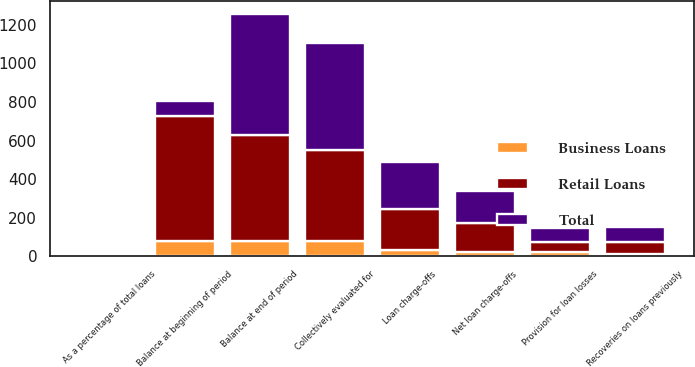Convert chart to OTSL. <chart><loc_0><loc_0><loc_500><loc_500><stacked_bar_chart><ecel><fcel>Balance at beginning of period<fcel>Loan charge-offs<fcel>Recoveries on loans previously<fcel>Net loan charge-offs<fcel>Provision for loan losses<fcel>Balance at end of period<fcel>As a percentage of total loans<fcel>Collectively evaluated for<nl><fcel>Retail Loans<fcel>648<fcel>212<fcel>65<fcel>147<fcel>51<fcel>552<fcel>1.3<fcel>476<nl><fcel>Business Loans<fcel>78<fcel>33<fcel>10<fcel>23<fcel>22<fcel>77<fcel>2.1<fcel>77<nl><fcel>Total<fcel>77<fcel>245<fcel>75<fcel>170<fcel>73<fcel>629<fcel>1.37<fcel>553<nl></chart> 